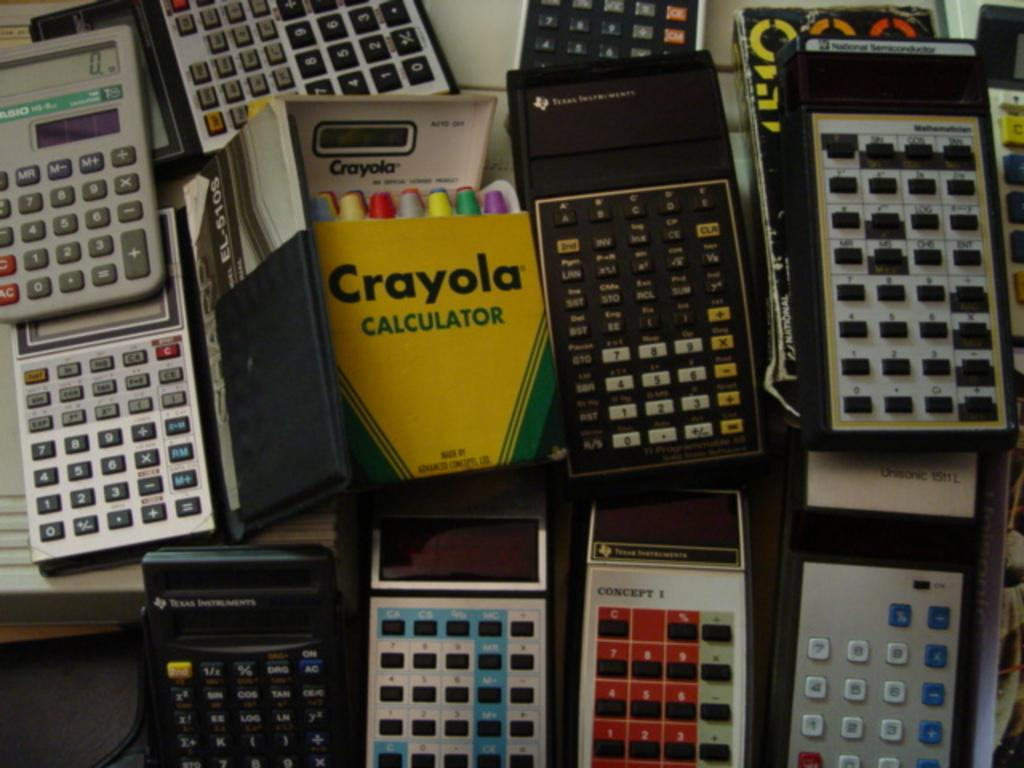<image>
Describe the image concisely. A colorful crayola calculator surrounded by traditional calculators 